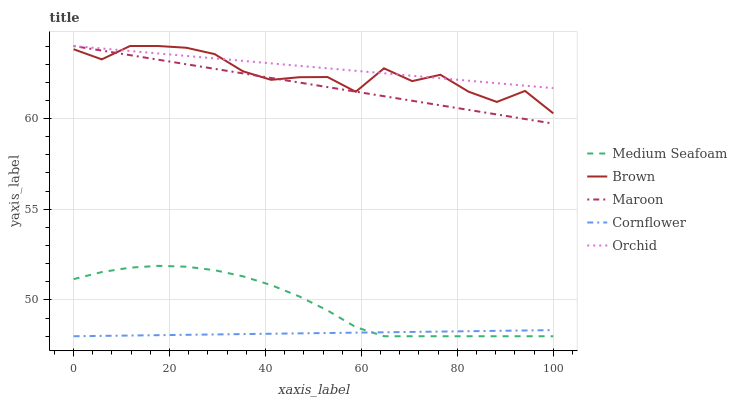Does Cornflower have the minimum area under the curve?
Answer yes or no. Yes. Does Orchid have the maximum area under the curve?
Answer yes or no. Yes. Does Medium Seafoam have the minimum area under the curve?
Answer yes or no. No. Does Medium Seafoam have the maximum area under the curve?
Answer yes or no. No. Is Orchid the smoothest?
Answer yes or no. Yes. Is Brown the roughest?
Answer yes or no. Yes. Is Medium Seafoam the smoothest?
Answer yes or no. No. Is Medium Seafoam the roughest?
Answer yes or no. No. Does Medium Seafoam have the lowest value?
Answer yes or no. Yes. Does Orchid have the lowest value?
Answer yes or no. No. Does Maroon have the highest value?
Answer yes or no. Yes. Does Medium Seafoam have the highest value?
Answer yes or no. No. Is Medium Seafoam less than Brown?
Answer yes or no. Yes. Is Orchid greater than Medium Seafoam?
Answer yes or no. Yes. Does Cornflower intersect Medium Seafoam?
Answer yes or no. Yes. Is Cornflower less than Medium Seafoam?
Answer yes or no. No. Is Cornflower greater than Medium Seafoam?
Answer yes or no. No. Does Medium Seafoam intersect Brown?
Answer yes or no. No. 